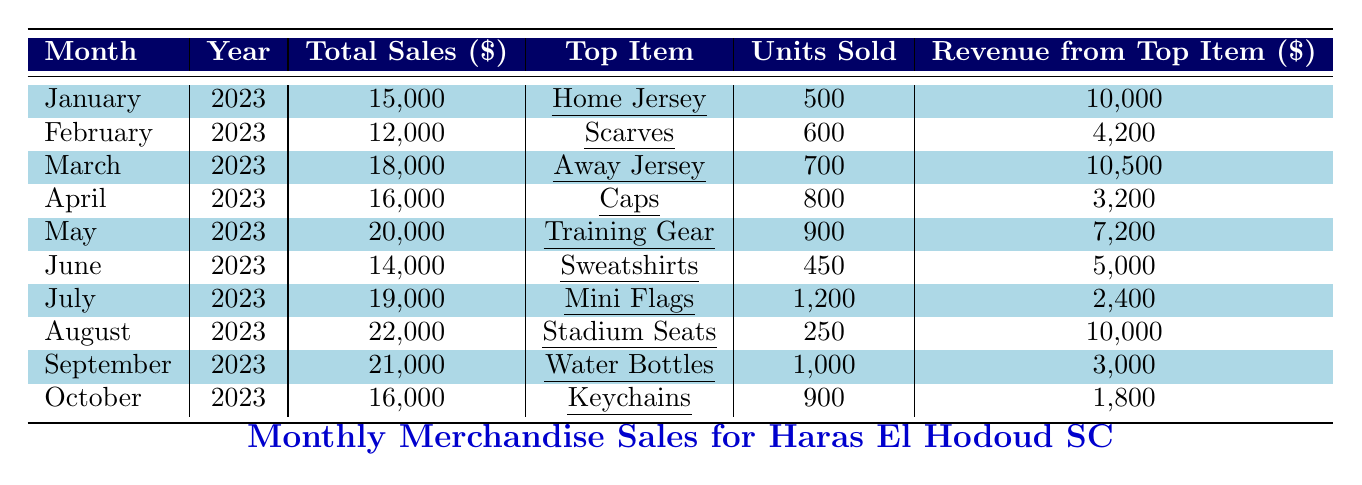What was the total merchandise sales in May 2023? The table shows that total merchandise sales for May 2023 are listed as 20,000.
Answer: 20,000 What was the top-selling item in September 2023? According to the table, the top-selling item in September 2023 is Water Bottles.
Answer: Water Bottles How many units of Scarves were sold in February 2023? The table indicates that 600 units of Scarves were sold in February 2023.
Answer: 600 What was the total revenue from the top item sold in March 2023? In March 2023, the revenue from the top item, Away Jersey, was 10,500.
Answer: 10,500 What was the average total sales from January to June 2023? To find the average, sum the total sales: (15,000 + 12,000 + 18,000 + 16,000 + 20,000 + 14,000) = 95,000. There are 6 months, so the average is 95,000 / 6 = 15,833.33.
Answer: 15,833.33 What is the difference in total sales between May and April 2023? The total sales for May is 20,000 and for April is 16,000. The difference is 20,000 - 16,000 = 4,000.
Answer: 4,000 In which month did sales of Mini Flags highest occur? The table shows that Mini Flags had a sales total of 19,000 in July, which is the highest in that month.
Answer: July Did more Water Bottles or Sweaters sell in total? Water Bottles sold 1,000 units in September while Sweatshirts sold 450 units in June, so more Water Bottles sold (1,000 > 450).
Answer: Yes What was the total revenue from top-selling items in August and September 2023 combined? The revenue from the top item, Stadium Seats in August is 10,000, and for Water Bottles in September is 3,000. Combined, that’s 10,000 + 3,000 = 13,000.
Answer: 13,000 Which month had the highest total sales, and what was the amount? The table states that August had the highest total sales at 22,000.
Answer: August, 22,000 